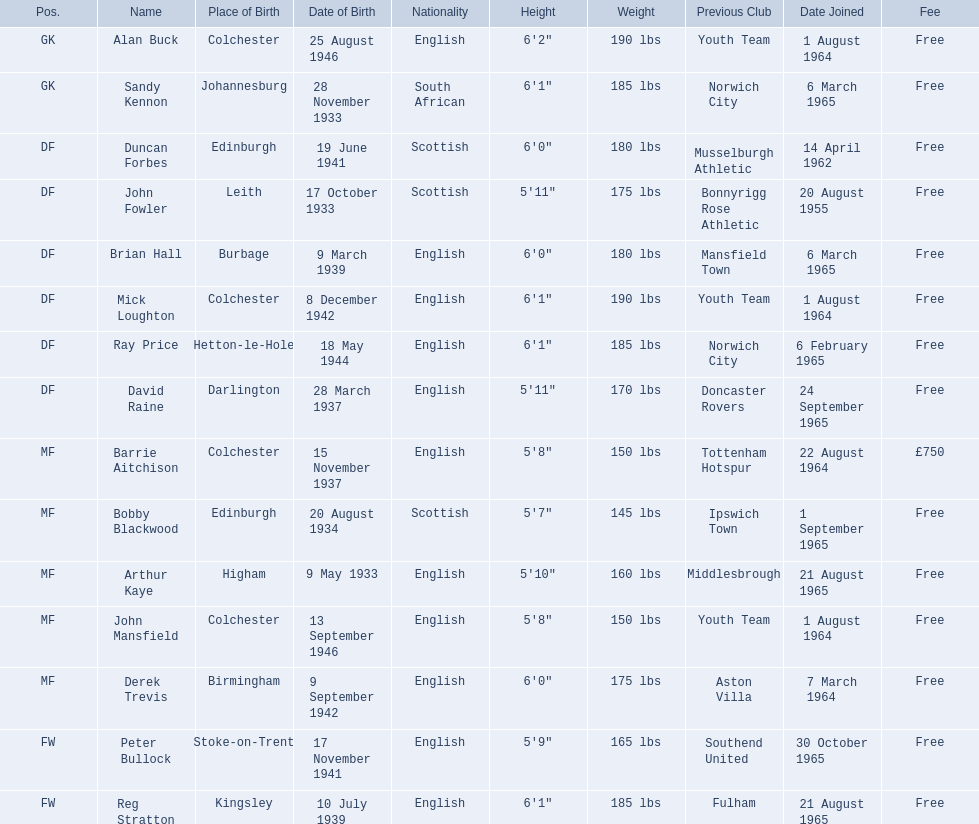When did each player join? 1 August 1964, 6 March 1965, 14 April 1962, 20 August 1955, 6 March 1965, 1 August 1964, 6 February 1965, 24 September 1965, 22 August 1964, 1 September 1965, 21 August 1965, 1 August 1964, 7 March 1964, 30 October 1965, 21 August 1965. And of those, which is the earliest join date? 20 August 1955. 